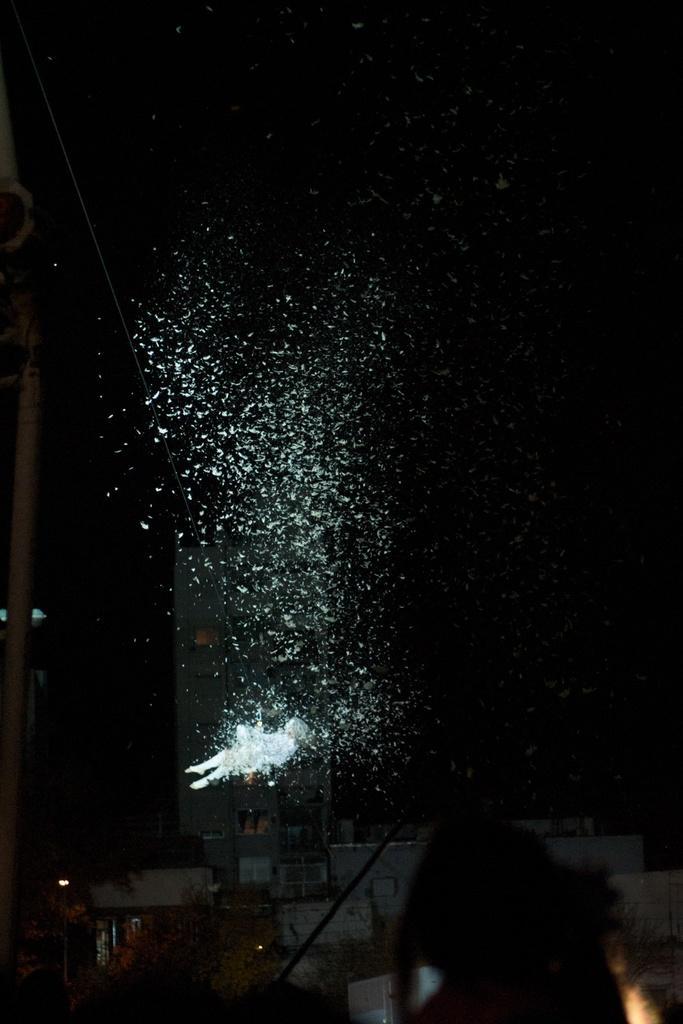In one or two sentences, can you explain what this image depicts? In this image there is an object which is white in colour and in the front there are objects which are black in colour. 